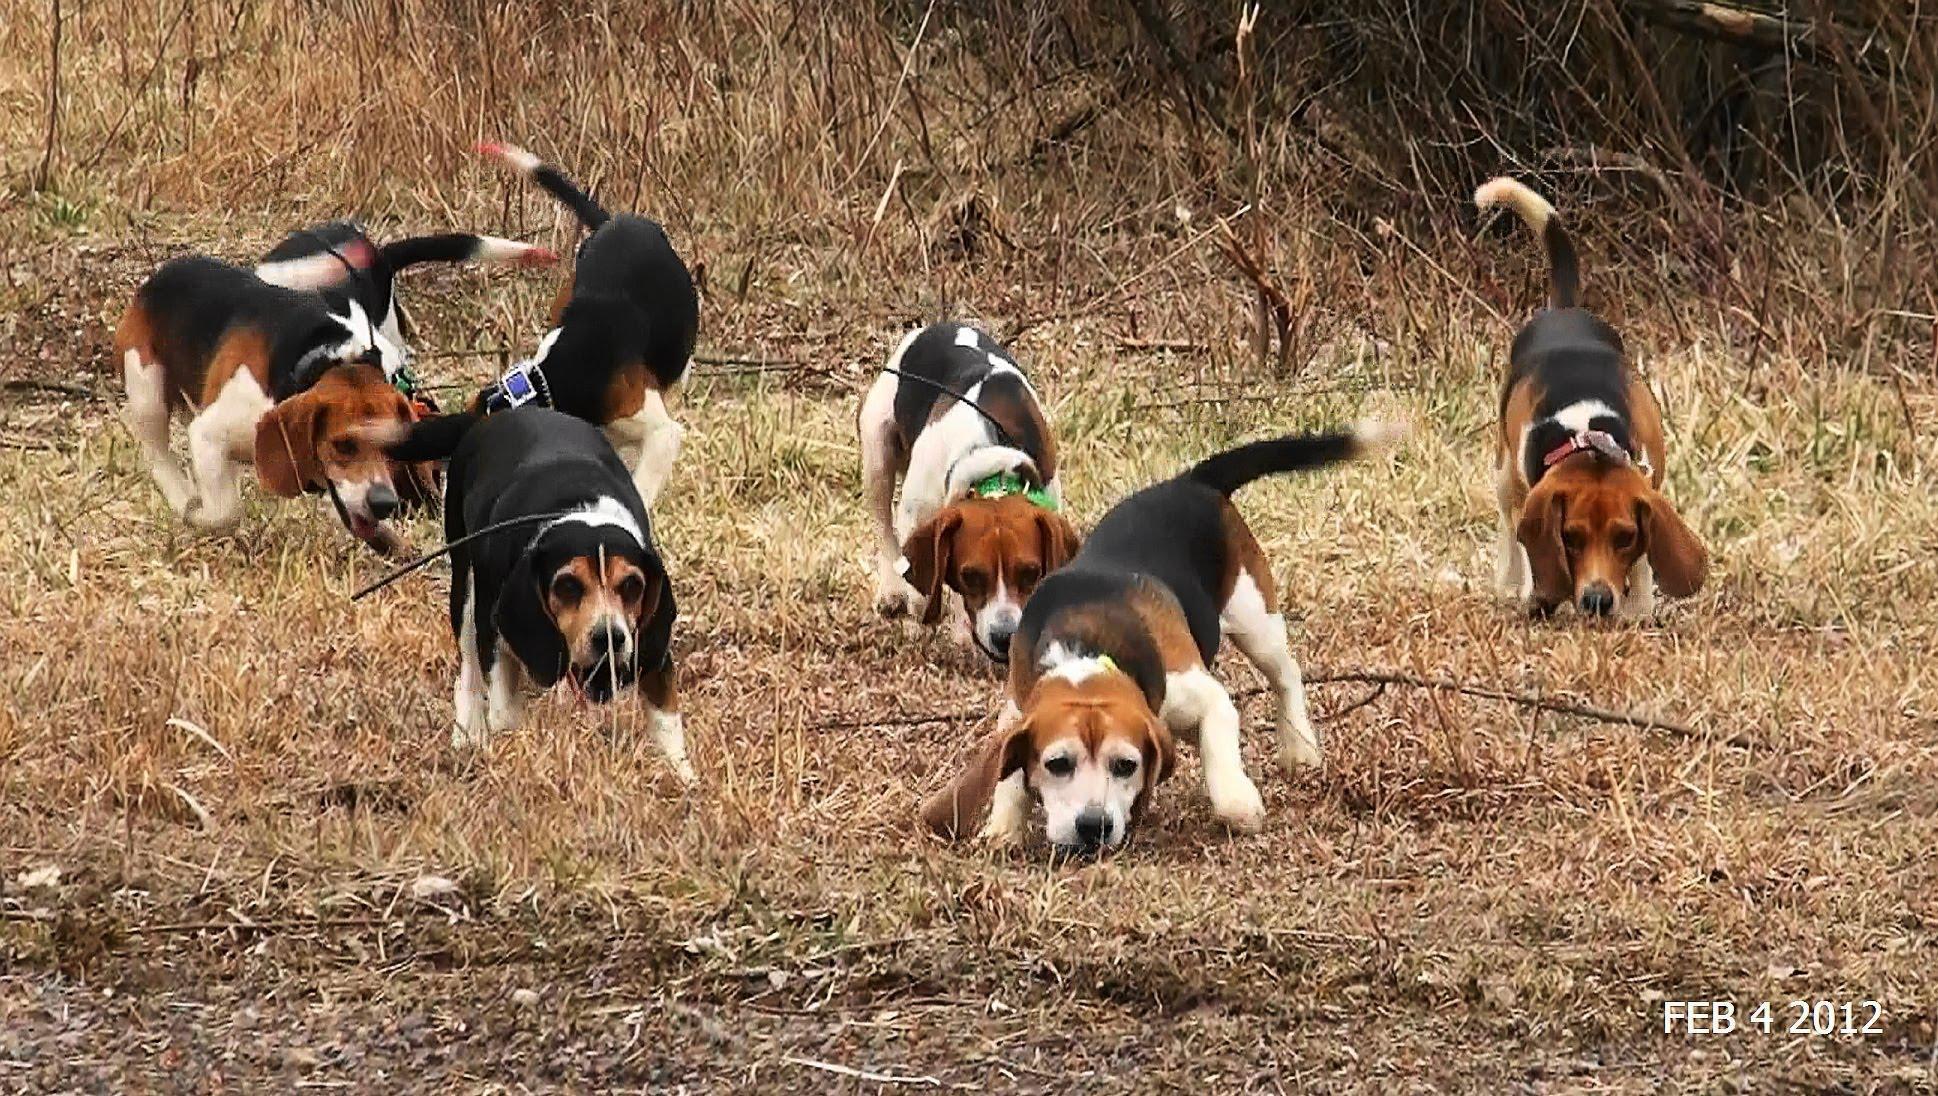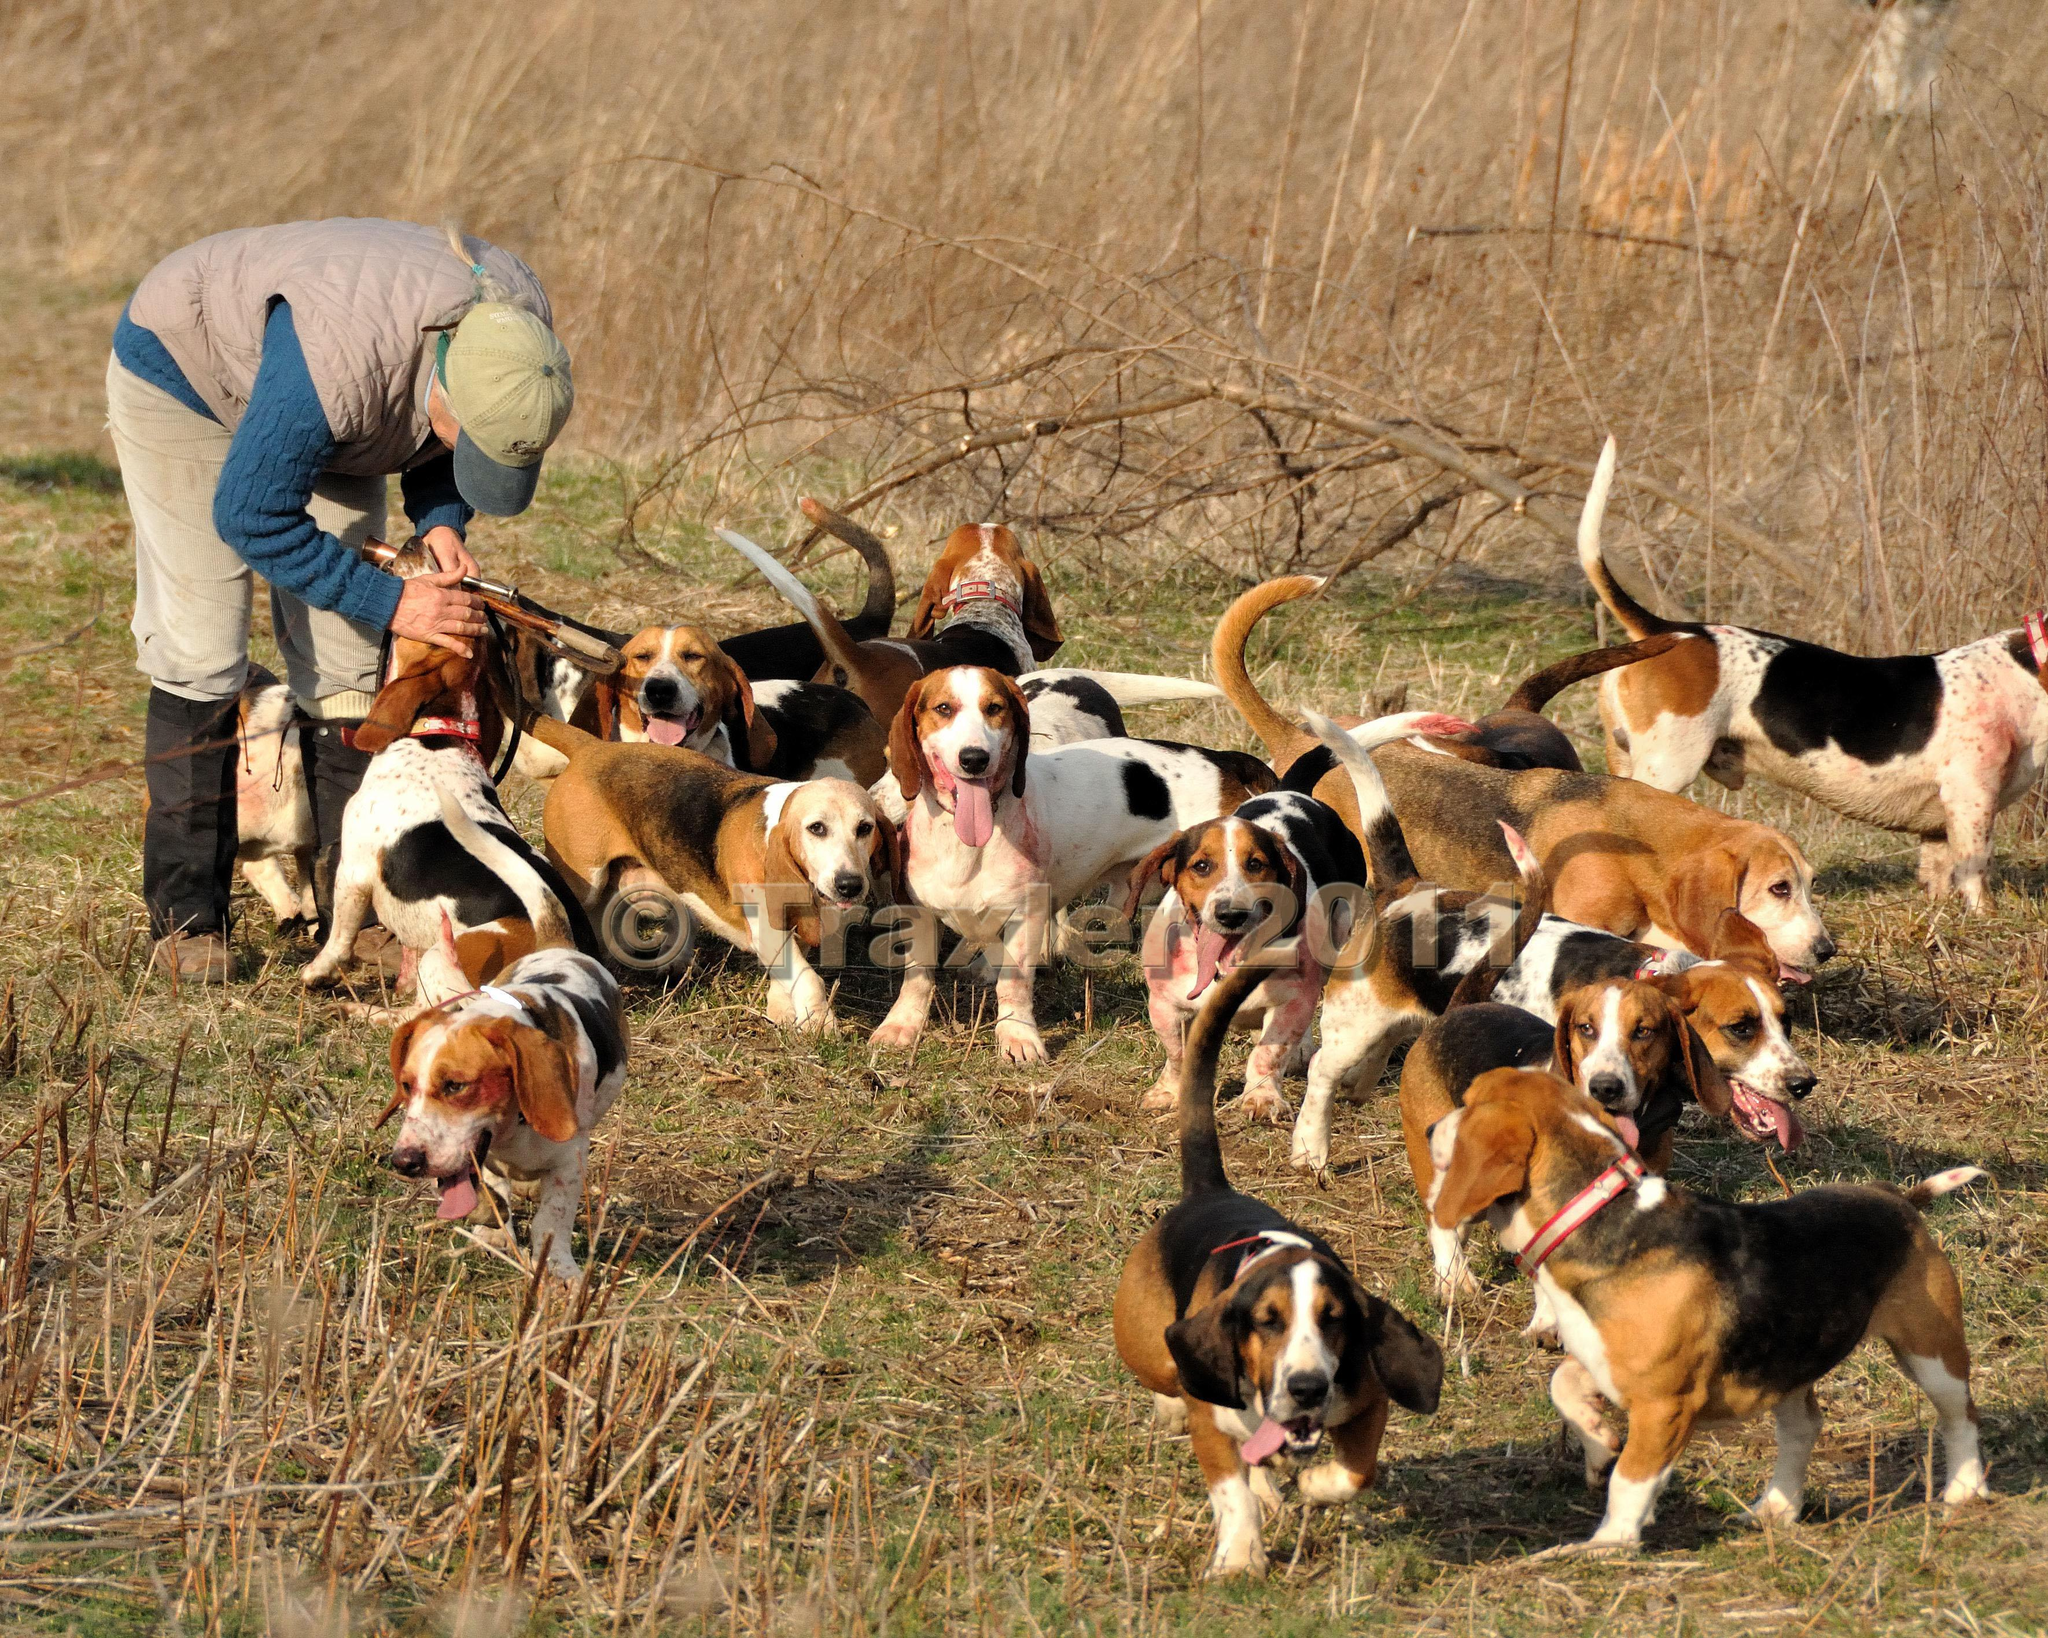The first image is the image on the left, the second image is the image on the right. Examine the images to the left and right. Is the description "All images contain at least one man in a hat." accurate? Answer yes or no. No. The first image is the image on the left, the second image is the image on the right. For the images shown, is this caption "There is a man wearing green and blue socks." true? Answer yes or no. No. 